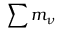<formula> <loc_0><loc_0><loc_500><loc_500>\sum m _ { \nu }</formula> 